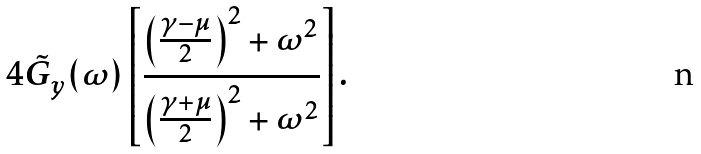<formula> <loc_0><loc_0><loc_500><loc_500>4 \tilde { G } _ { y } ( \omega ) \left [ \frac { \left ( \frac { \gamma - \mu } { 2 } \right ) ^ { 2 } + \omega ^ { 2 } } { \left ( \frac { \gamma + \mu } { 2 } \right ) ^ { 2 } + \omega ^ { 2 } } \right ] .</formula> 